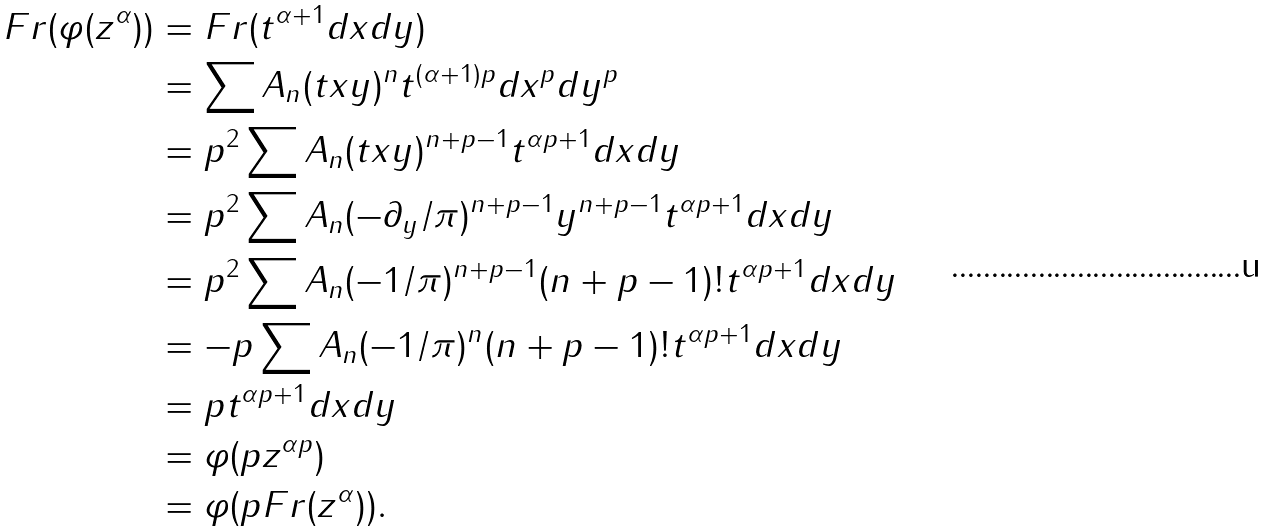<formula> <loc_0><loc_0><loc_500><loc_500>F r ( \varphi ( z ^ { \alpha } ) ) & = F r ( t ^ { \alpha + 1 } d x d y ) \\ & = \sum A _ { n } ( t x y ) ^ { n } t ^ { ( \alpha + 1 ) p } d x ^ { p } d y ^ { p } \\ & = p ^ { 2 } \sum A _ { n } ( t x y ) ^ { n + p - 1 } t ^ { \alpha p + 1 } d x d y \\ & = p ^ { 2 } \sum A _ { n } ( - \partial _ { y } / \pi ) ^ { n + p - 1 } y ^ { n + p - 1 } t ^ { \alpha p + 1 } d x d y \\ & = p ^ { 2 } \sum A _ { n } ( - 1 / \pi ) ^ { n + p - 1 } ( n + p - 1 ) ! t ^ { \alpha p + 1 } d x d y \\ & = - p \sum A _ { n } ( - 1 / \pi ) ^ { n } ( n + p - 1 ) ! t ^ { \alpha p + 1 } d x d y \\ & = p t ^ { \alpha p + 1 } d x d y \\ & = \varphi ( p z ^ { \alpha p } ) \\ & = \varphi ( p F r ( z ^ { \alpha } ) ) .</formula> 